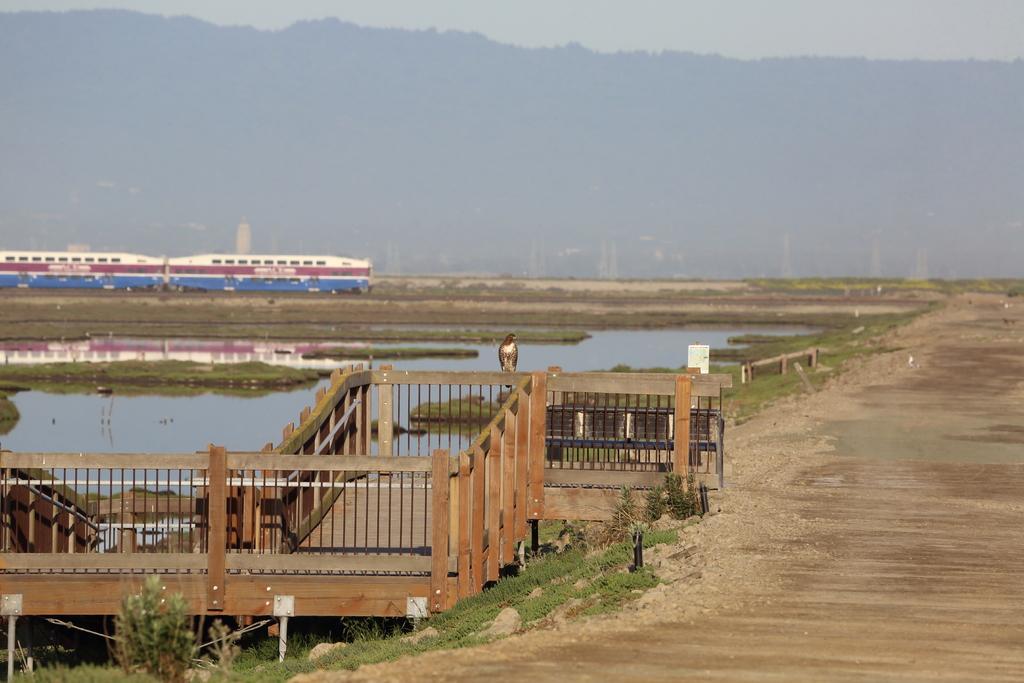How would you summarize this image in a sentence or two? In the image there is a wooden bridge, behind the bridge there is a water surface and around the water surface there is a lot of empty land and in the background it seems like there is a train and mountains. 